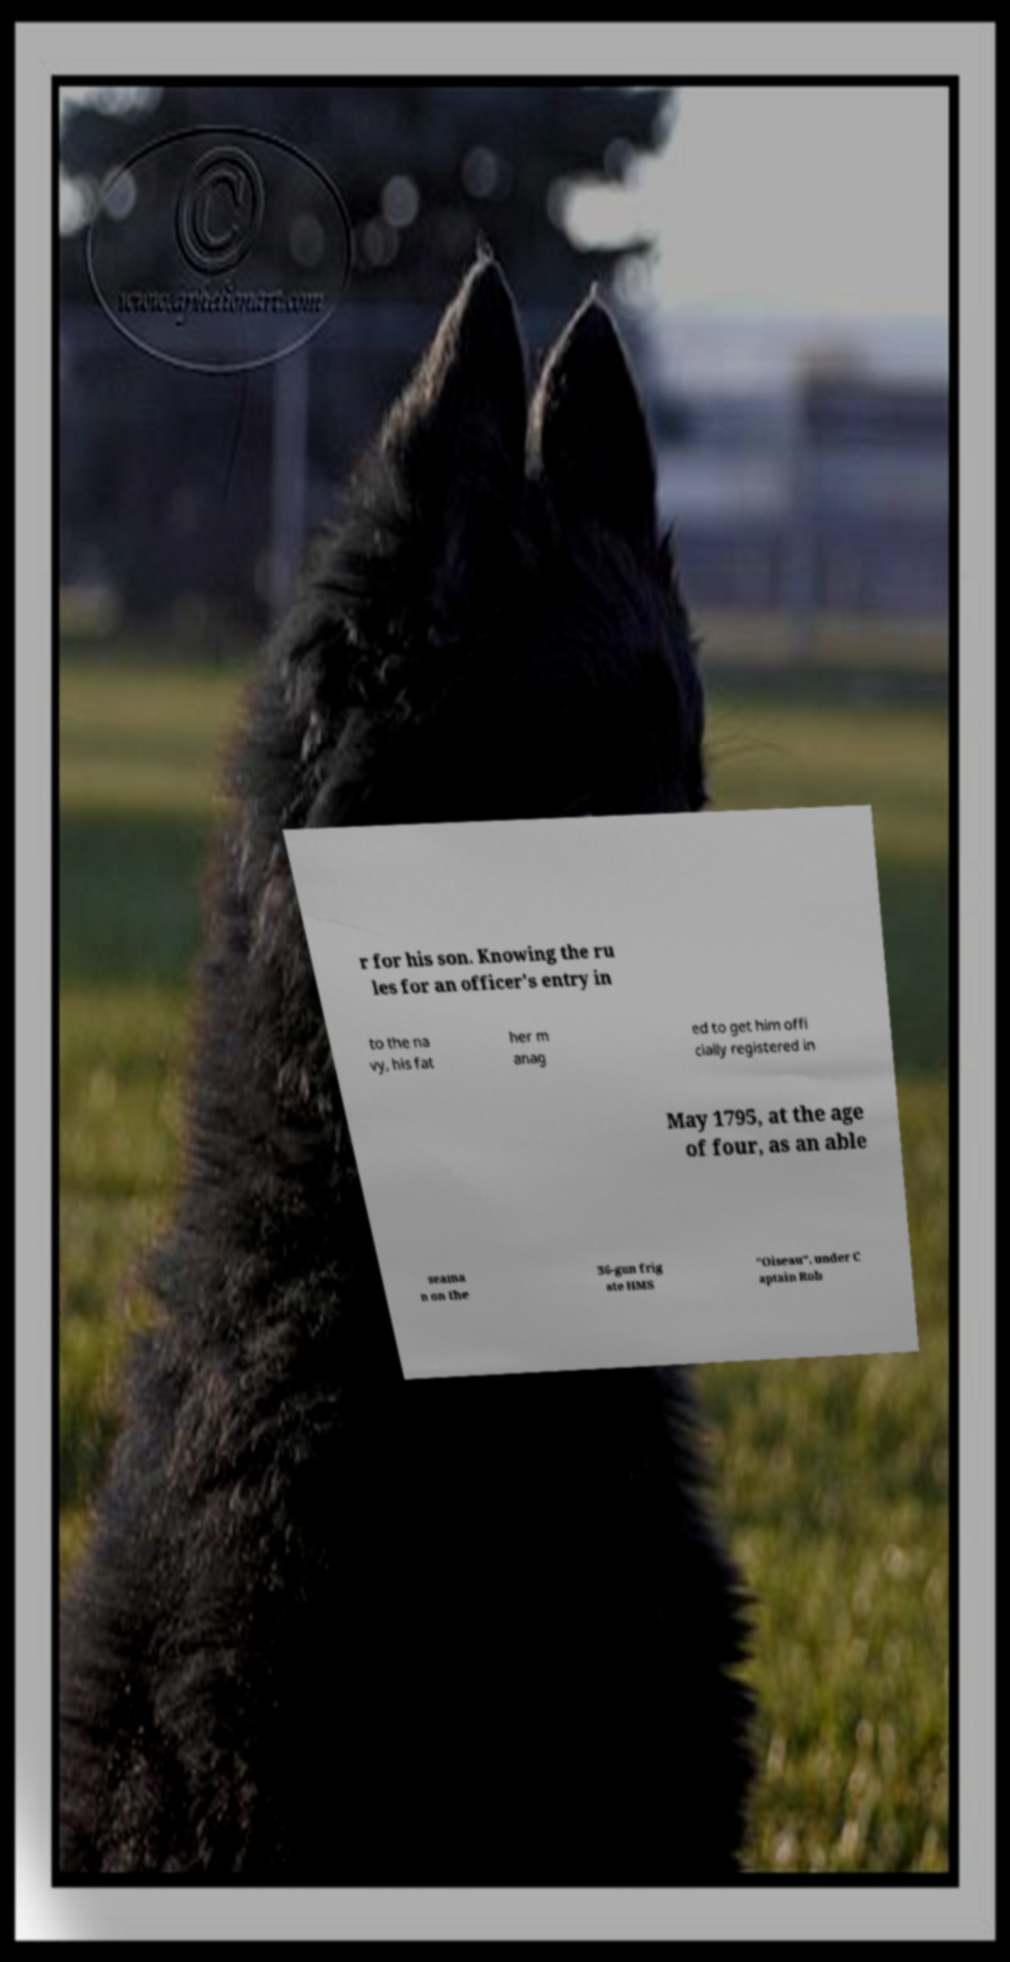I need the written content from this picture converted into text. Can you do that? r for his son. Knowing the ru les for an officer's entry in to the na vy, his fat her m anag ed to get him offi cially registered in May 1795, at the age of four, as an able seama n on the 36-gun frig ate HMS "Oiseau", under C aptain Rob 